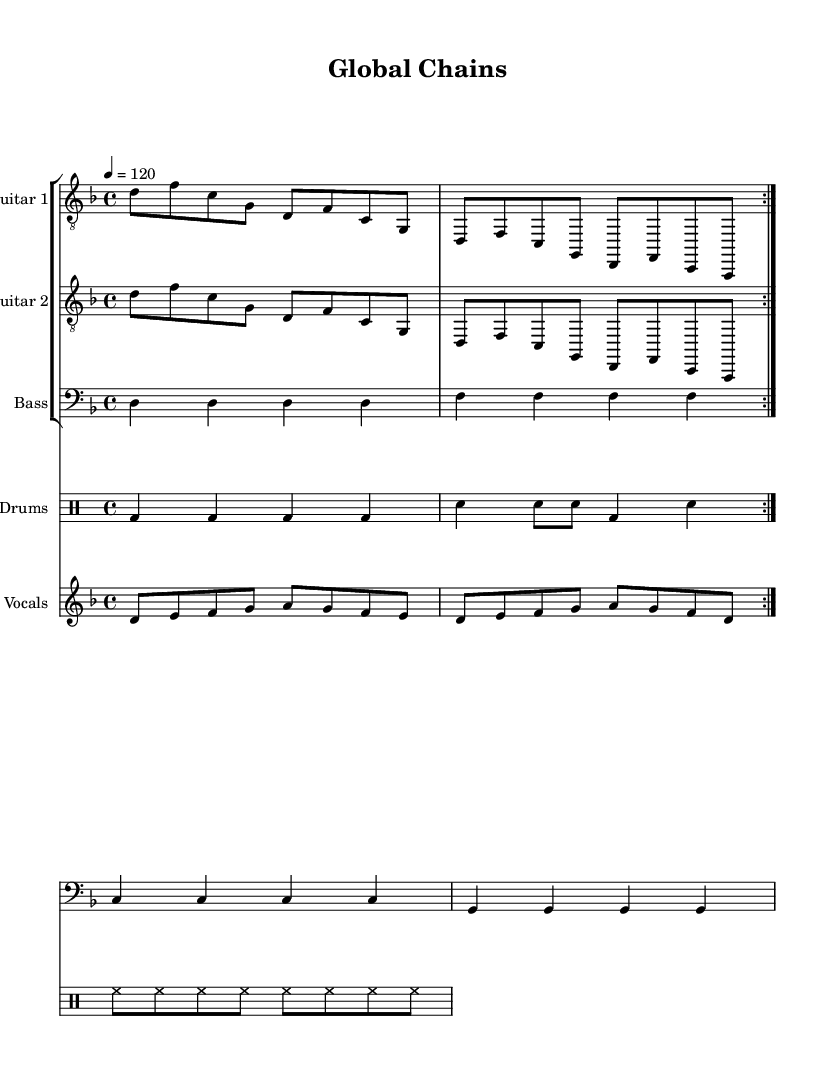What is the key signature of this music? The key signature is indicated at the beginning of the staff. It shows one flat, confirming that it is in the key of D minor.
Answer: D minor What is the time signature of this music? The time signature is shown at the beginning of the score. It is presented as 4/4, which indicates that there are four beats per measure, and each quarter note gets one beat.
Answer: 4/4 What is the tempo of the music? The tempo marking indicates the speed of the song. It is specified as quarter note equals 120 beats per minute, which tells performers how fast to play.
Answer: 120 How many measures are in the guitar parts? By counting the repeated sections in each guitar part, there are a total of four measures repeated two times according to the volta, yielding eight measures.
Answer: 8 What type of musical piece is this? The piece is classified under the metal genre, emphasizing groove metal, which is identifiable through its heavy guitar riffs and aggressive rhythms.
Answer: Metal What do the lyrics address in the song? The lyrics reference themes of economic imperialism, focusing on concepts of exploitation and corporate greed which is a common subject in heavy metal music, particularly within groove metal.
Answer: Economic imperialism What is the role of the drums in this composition? The drum part serves as the backbone of the rhythm section, providing consistent beats and accents that support the overall heavy feel of the groove metal style with a focus on bass and snare hits.
Answer: Rhythm backbone 